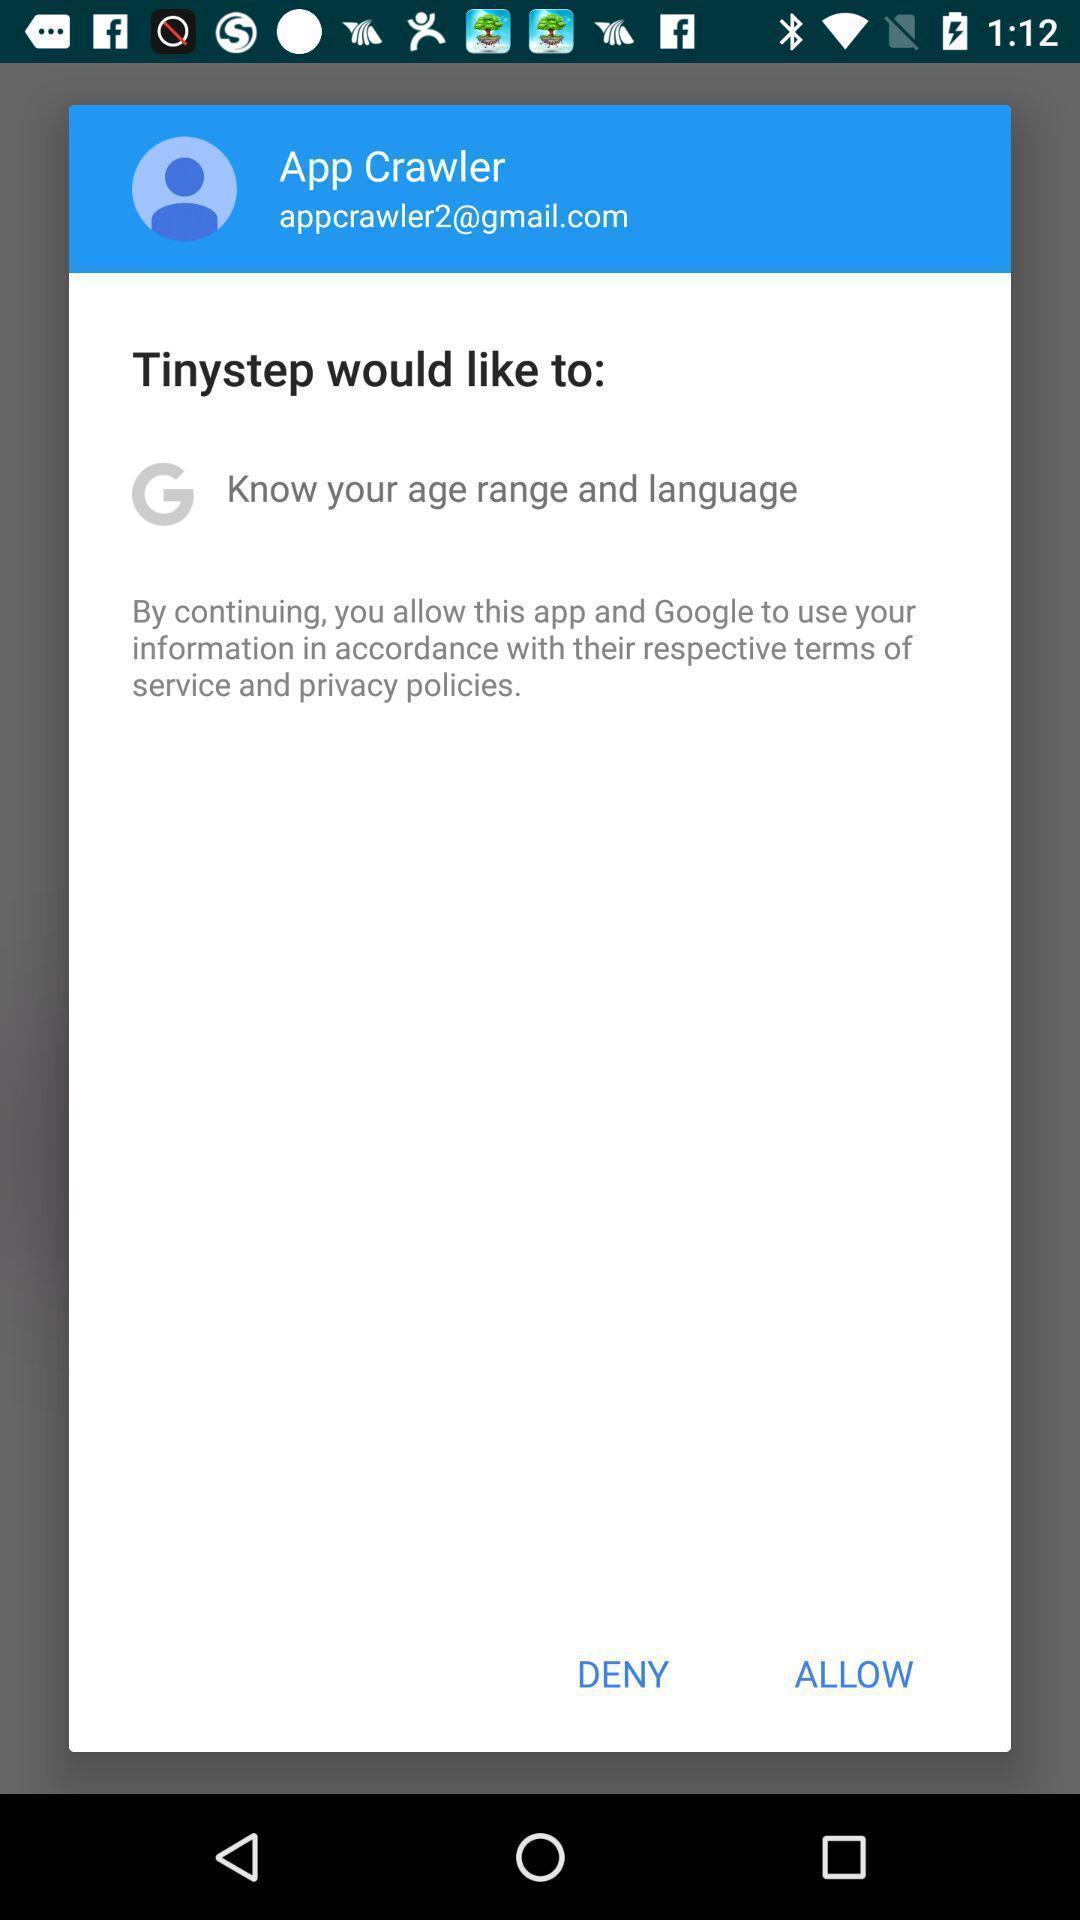Provide a textual representation of this image. Pop-up for allow or deny to know age and language. 